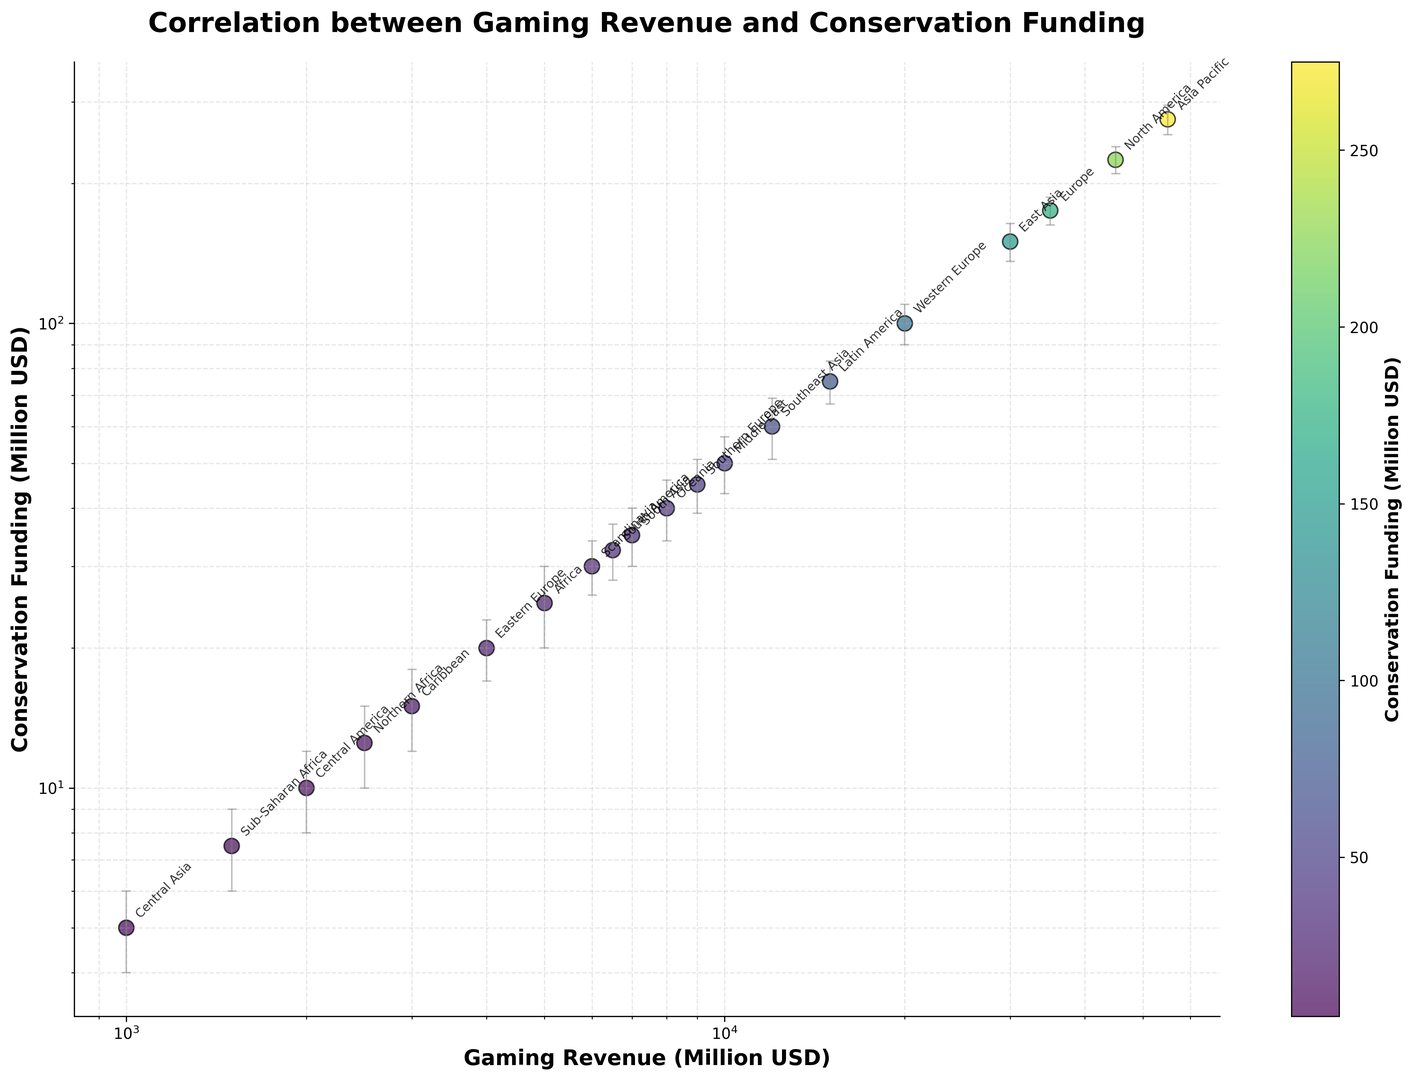Which region has the highest gaming revenue? The figure shows a scatter plot of Gaming Revenue vs. Conservation Funding. The region with the highest gaming revenue is located at the far right end of the x-axis. According to the plot, Asia Pacific has the highest gaming revenue.
Answer: Asia Pacific What is the approximate difference in conservation funding between North America and Europe? By observing the y-axis positions of North America and Europe, we see that North America's conservation funding is around 225 million USD and Europe's is around 175 million USD. The difference is 225 - 175 = 50 million USD.
Answer: 50 million USD Which region has the largest margin of error in conservation funding, and how does it compare to Southeast Asia's margin of error? The error bars in the plot represent the margin of error. Asia Pacific has the largest margin of error at 20 million USD. Southeast Asia has an error margin of 9 million USD. Therefore, Asia Pacific's margin of error is larger.
Answer: Asia Pacific, larger What can be said about the trend between gaming revenue and conservation funding? The scatter plot suggests a positive correlation as regions with higher gaming revenues also tend to have higher conservation funding. Both axes use a log scale which further emphasizes this trend.
Answer: Positive correlation Which region shows the smallest conservation funding, and approximately how much is it? The region with the smallest y-axis position on the scatter plot has the lowest conservation funding. Central Asia, situated at the bottom of the plot, shows the smallest conservation funding of approximately 5 million USD.
Answer: Central Asia, 5 million USD Compare the gaming revenue and conservation funding between East Asia and Eastern Europe. Observing the plot, East Asia has a gaming revenue and conservation funding of approximately 30,000 million USD and 150 million USD, respectively. Eastern Europe has around 4,000 million USD in gaming revenue and 20 million USD in conservation funding. East Asia has significantly higher values in both metrics compared to Eastern Europe.
Answer: East Asia has higher values in both metrics On which side of the plot are most regions located based on their conservation funding? The regions are mostly located towards the lower left side of the plot since many regions have lower conservation funding and lower gaming revenue, which clusters them in that area.
Answer: Lower left side 